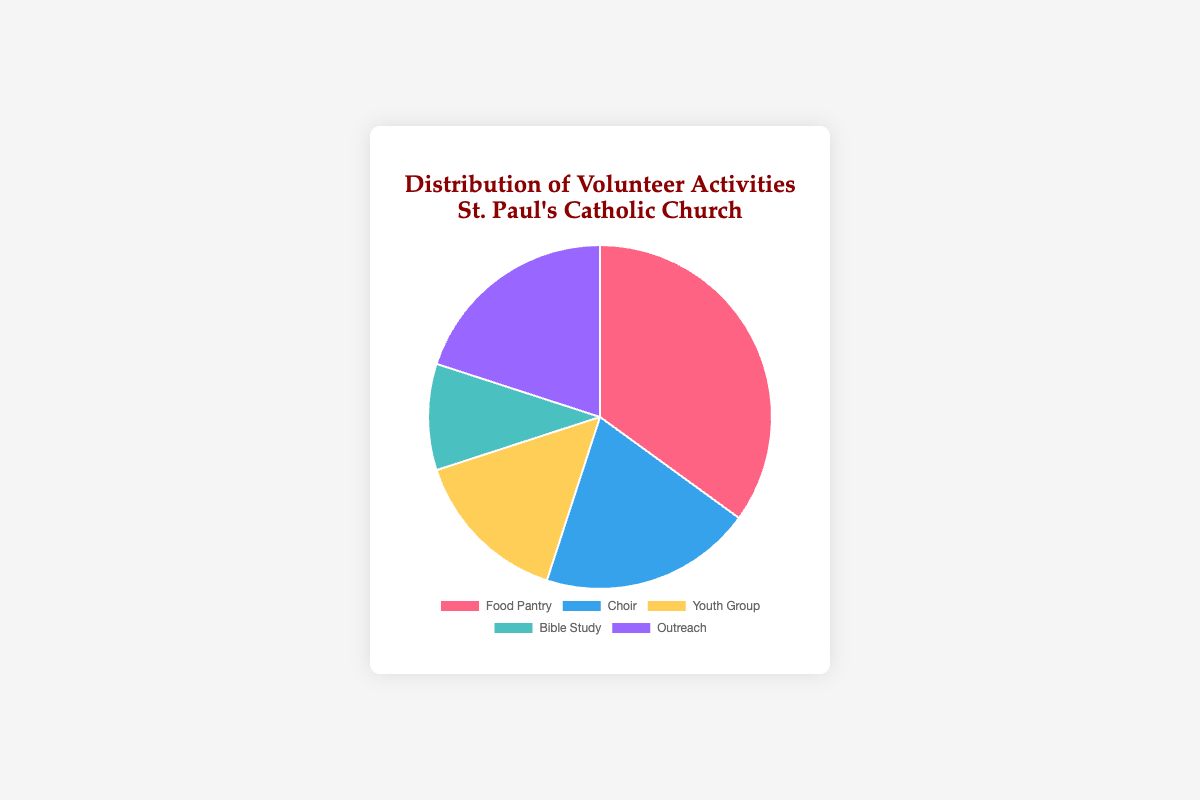What percentage of the volunteer activities at St. Paul's Catholic Church is dedicated to the Food Pantry? The Food Pantry is one of the segments in the pie chart, and its corresponding percentage is 35%.
Answer: 35% Which two volunteer activities have an equal percentage of participation? By inspecting the pie chart, both "Choir" and "Outreach" have the same segment sizes, each representing 20% of the total volunteer activities.
Answer: Choir and Outreach What is the combined percentage of the Youth Group and Bible Study? From the pie chart, the Youth Group has 15% and the Bible Study has 10%. Adding these two percentages together gives us 15% + 10% = 25%.
Answer: 25% Which volunteer activity has the smallest participation percentage? The smallest segment in the pie chart corresponds to the Bible Study, with a percentage of 10%.
Answer: Bible Study Is the Food Pantry participation greater than the combined participation of Bible Study and Outreach? Checking the pie chart, the Food Pantry is 35%. The combined percentage of Bible Study (10%) and Outreach (20%) is 10% + 20% = 30%. Since 35% > 30%, Food Pantry participation is indeed greater.
Answer: Yes Compare the Choir participation to the Youth Group participation. Which one is greater and by how much? The pie chart shows the Choir at 20% and the Youth Group at 15%. The difference is 20% - 15% = 5%. Therefore, Choir participation is greater by 5%.
Answer: Choir by 5% What is the total percentage of the activities other than the Food Pantry? The percentages for activities other than the Food Pantry are Choir (20%), Youth Group (15%), Bible Study (10%), and Outreach (20%). Adding these gives us 20% + 15% + 10% + 20% = 65%.
Answer: 65% Which activity is represented by the blue segment in the pie chart? The color coding in the pie chart indicates that the 20% segment represented by blue corresponds to the Choir.
Answer: Choir How many activities have a percentage distribution of 20%? By checking the pie chart, the activities Choir and Outreach both have a distribution of 20%. Thus, there are two activities with this percentage.
Answer: 2 What is the difference in participation between the activity with the highest and the lowest percentages? The highest percentage is for Food Pantry at 35%, and the lowest is for Bible Study at 10%. The difference is 35% - 10% = 25%.
Answer: 25% 